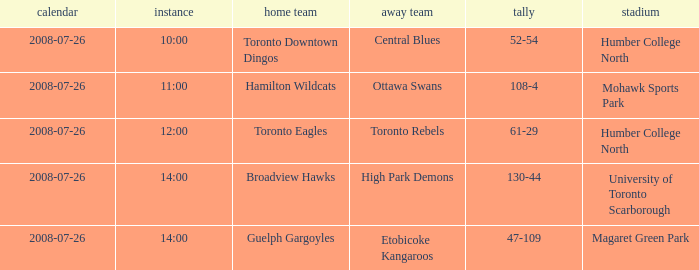The Away High Park Demons was which Ground? University of Toronto Scarborough. 